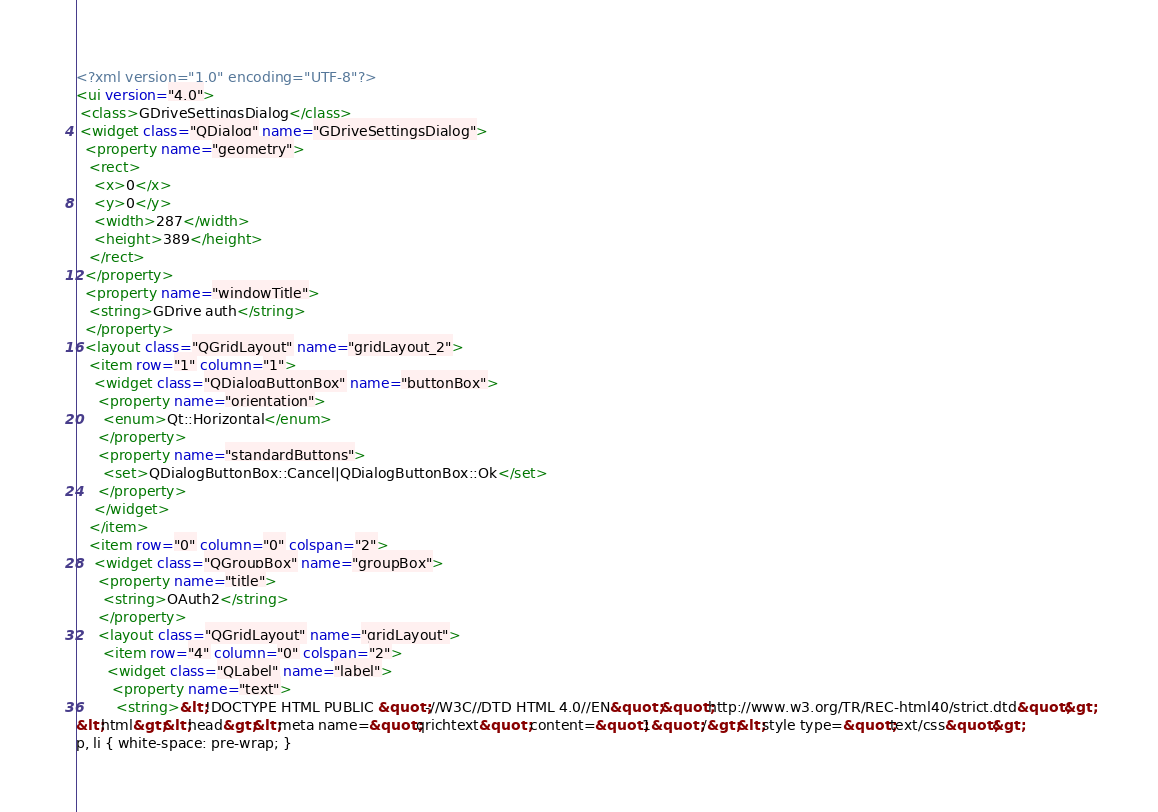Convert code to text. <code><loc_0><loc_0><loc_500><loc_500><_XML_><?xml version="1.0" encoding="UTF-8"?>
<ui version="4.0">
 <class>GDriveSettingsDialog</class>
 <widget class="QDialog" name="GDriveSettingsDialog">
  <property name="geometry">
   <rect>
    <x>0</x>
    <y>0</y>
    <width>287</width>
    <height>389</height>
   </rect>
  </property>
  <property name="windowTitle">
   <string>GDrive auth</string>
  </property>
  <layout class="QGridLayout" name="gridLayout_2">
   <item row="1" column="1">
    <widget class="QDialogButtonBox" name="buttonBox">
     <property name="orientation">
      <enum>Qt::Horizontal</enum>
     </property>
     <property name="standardButtons">
      <set>QDialogButtonBox::Cancel|QDialogButtonBox::Ok</set>
     </property>
    </widget>
   </item>
   <item row="0" column="0" colspan="2">
    <widget class="QGroupBox" name="groupBox">
     <property name="title">
      <string>OAuth2</string>
     </property>
     <layout class="QGridLayout" name="gridLayout">
      <item row="4" column="0" colspan="2">
       <widget class="QLabel" name="label">
        <property name="text">
         <string>&lt;!DOCTYPE HTML PUBLIC &quot;-//W3C//DTD HTML 4.0//EN&quot; &quot;http://www.w3.org/TR/REC-html40/strict.dtd&quot;&gt;
&lt;html&gt;&lt;head&gt;&lt;meta name=&quot;qrichtext&quot; content=&quot;1&quot; /&gt;&lt;style type=&quot;text/css&quot;&gt;
p, li { white-space: pre-wrap; }</code> 